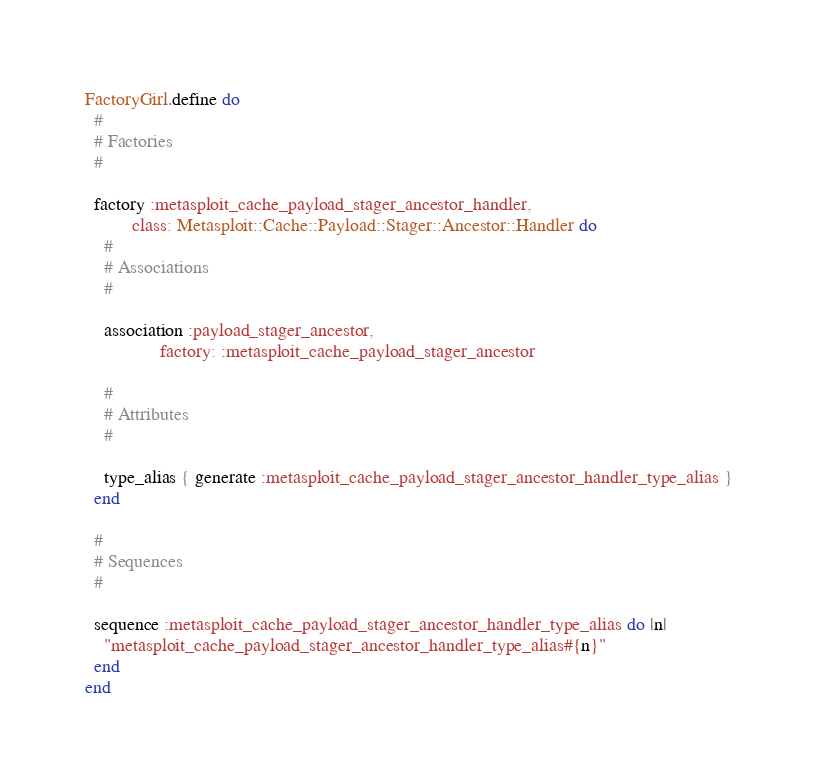<code> <loc_0><loc_0><loc_500><loc_500><_Ruby_>FactoryGirl.define do
  #
  # Factories
  #

  factory :metasploit_cache_payload_stager_ancestor_handler,
          class: Metasploit::Cache::Payload::Stager::Ancestor::Handler do
    #
    # Associations
    #

    association :payload_stager_ancestor,
                factory: :metasploit_cache_payload_stager_ancestor

    #
    # Attributes
    #

    type_alias { generate :metasploit_cache_payload_stager_ancestor_handler_type_alias }
  end

  #
  # Sequences
  #

  sequence :metasploit_cache_payload_stager_ancestor_handler_type_alias do |n|
    "metasploit_cache_payload_stager_ancestor_handler_type_alias#{n}"
  end
end</code> 